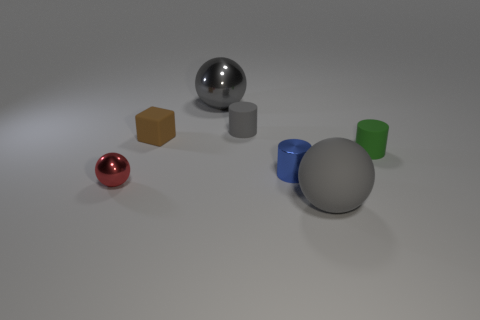Subtract all red cubes. How many gray balls are left? 2 Add 3 big shiny things. How many objects exist? 10 Subtract all cylinders. How many objects are left? 4 Subtract all tiny cyan spheres. Subtract all big rubber balls. How many objects are left? 6 Add 1 tiny matte cubes. How many tiny matte cubes are left? 2 Add 7 tiny green things. How many tiny green things exist? 8 Subtract 0 yellow cylinders. How many objects are left? 7 